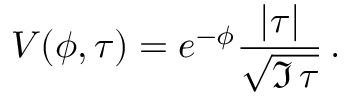<formula> <loc_0><loc_0><loc_500><loc_500>V ( \phi , \tau ) = e ^ { - \phi } { \frac { | \tau | } { \sqrt { \Im \, \tau } } } \, .</formula> 